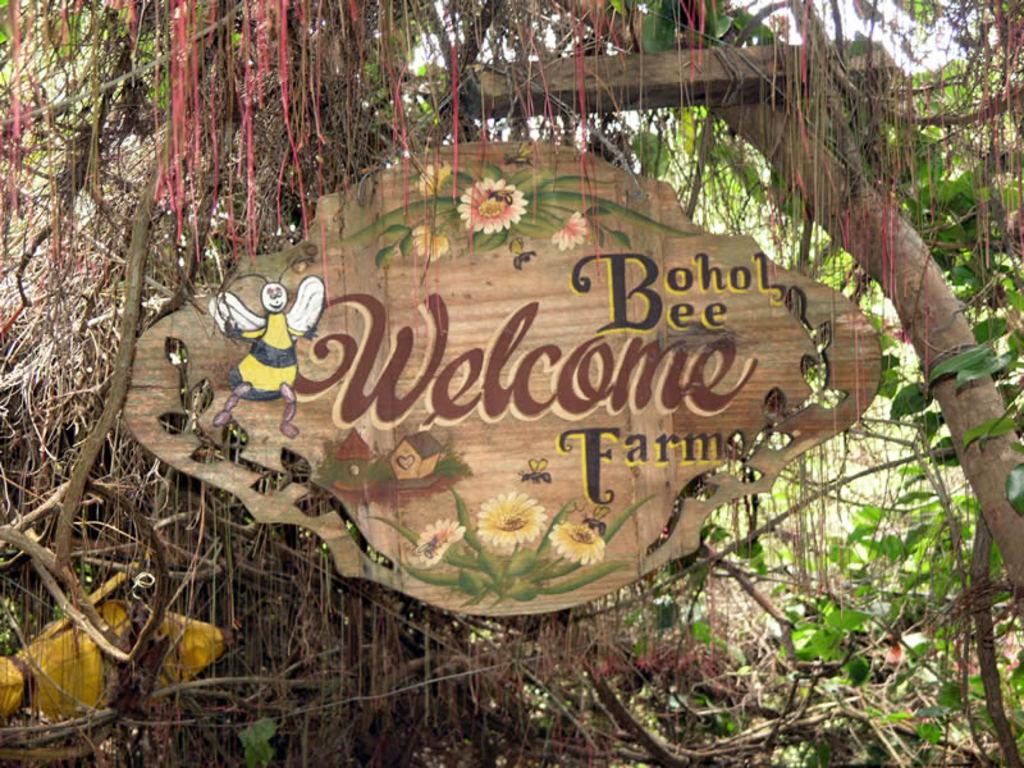What is the main object in the image with a design on it? There is a name board with a design in the image. What type of natural elements can be seen in the image? There are trees with branches and leaves in the image. What shape is the ball in the image? There is no ball present in the image. 